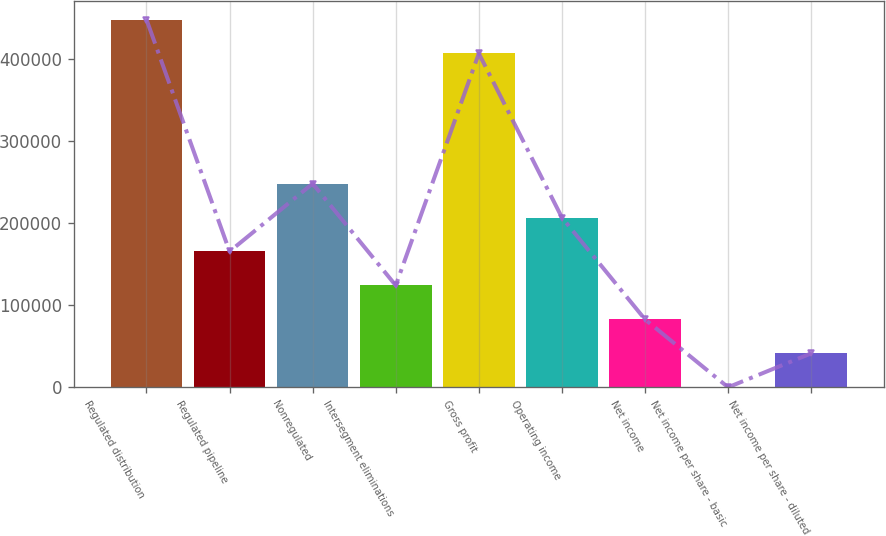Convert chart to OTSL. <chart><loc_0><loc_0><loc_500><loc_500><bar_chart><fcel>Regulated distribution<fcel>Regulated pipeline<fcel>Nonregulated<fcel>Intersegment eliminations<fcel>Gross profit<fcel>Operating income<fcel>Net income<fcel>Net income per share - basic<fcel>Net income per share - diluted<nl><fcel>448734<fcel>165691<fcel>248536<fcel>124268<fcel>407311<fcel>207113<fcel>82845.8<fcel>0.69<fcel>41423.2<nl></chart> 